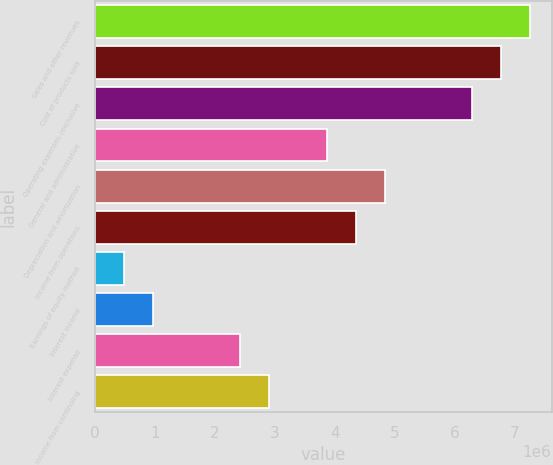<chart> <loc_0><loc_0><loc_500><loc_500><bar_chart><fcel>Sales and other revenues<fcel>Cost of products sold<fcel>Operating expenses (exclusive<fcel>General and administrative<fcel>Depreciation and amortization<fcel>Income from operations<fcel>Earnings of equity method<fcel>Interest income<fcel>Interest expense<fcel>Income from continuing<nl><fcel>7.2514e+06<fcel>6.76798e+06<fcel>6.28455e+06<fcel>3.86741e+06<fcel>4.83427e+06<fcel>4.35084e+06<fcel>483427<fcel>966854<fcel>2.41713e+06<fcel>2.90056e+06<nl></chart> 